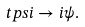<formula> <loc_0><loc_0><loc_500><loc_500>\ t p s i \to i \psi .</formula> 